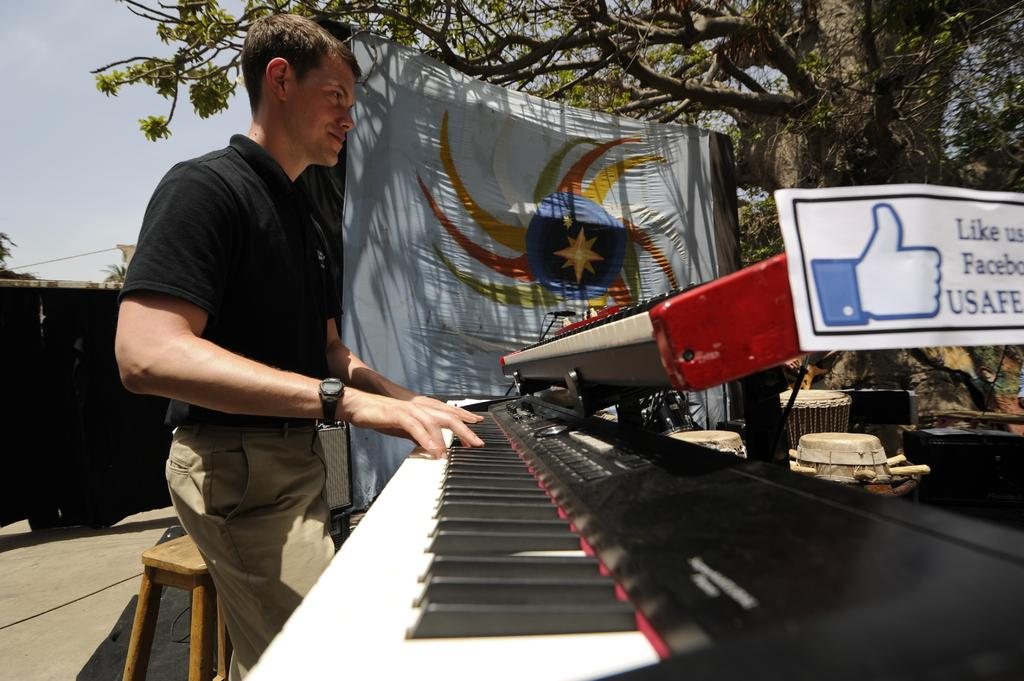What is the person in the image doing? The person is standing and playing a piano keyboard. What can be seen in the background of the image? There is a banner attached to a tree in the background. What other musical instruments are present in the image? There are musical instruments in the image. What is attached to the piano? A poster is attached to the piano. What type of reward can be seen on the piano keyboard? There is no reward present on the piano keyboard; it is a musical instrument being played by a person. 